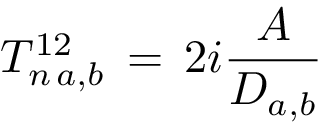Convert formula to latex. <formula><loc_0><loc_0><loc_500><loc_500>T _ { n \, a , b } ^ { 1 2 } \, = \, 2 i \frac { A } { D _ { a , b } }</formula> 